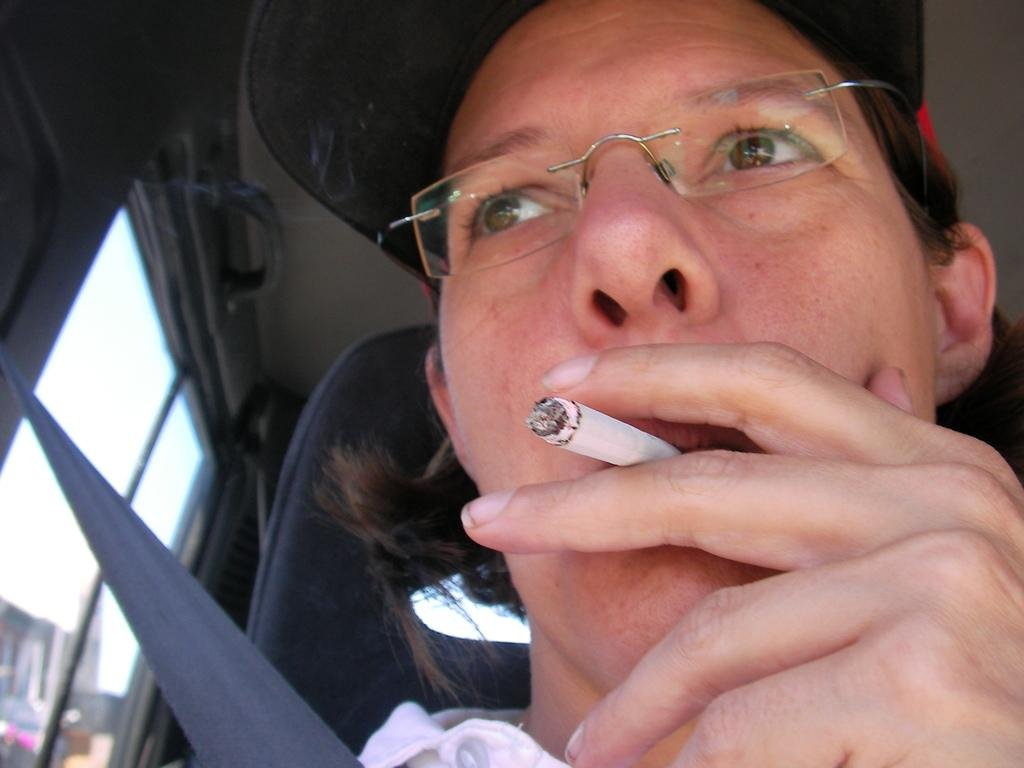What is the main subject of the image? The main subject of the image is a man. What is the man doing in the image? The man is seated in a vehicle. What accessories is the man wearing in the image? The man is wearing spectacles and a cap. What activity is the man engaged in while seated in the vehicle? The man is smoking a cigarette. How is the man holding the cigarette in the image? The man is holding the cigarette in his hand. What type of hill can be seen in the background of the image? There is no hill visible in the image; it is focused on the man seated in the vehicle. 